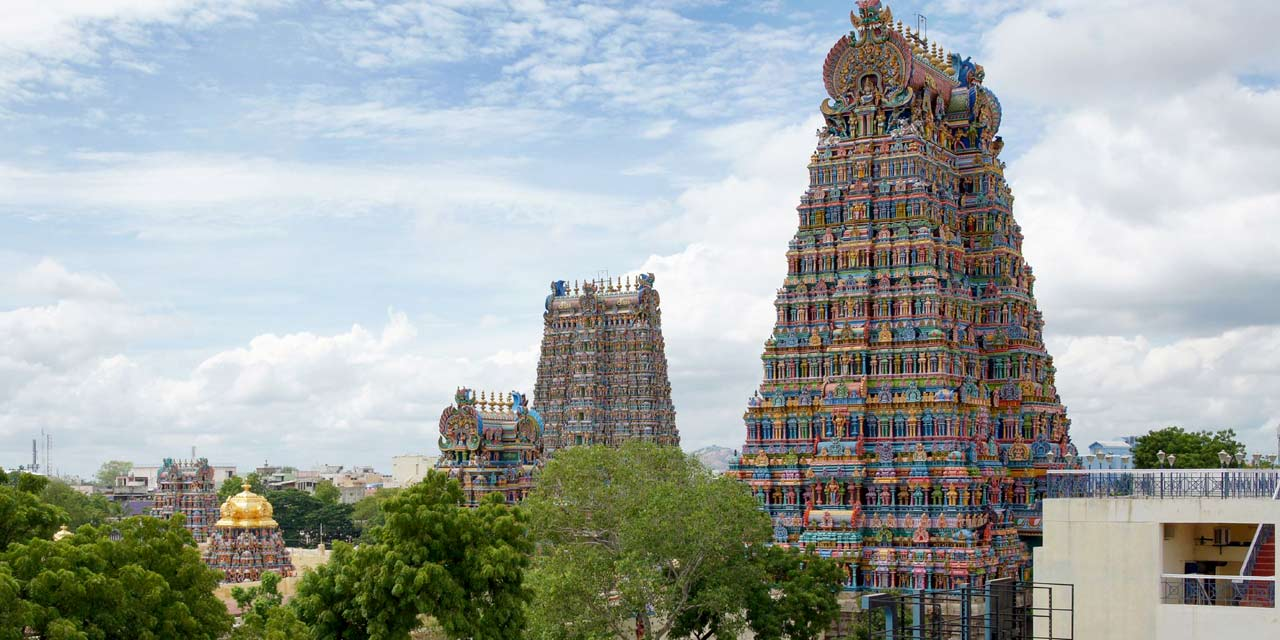Imagine a day in the life of one of the statues on the temple. What experiences would it have? As the sun rises, casting a warm glow on the temple’s facade, the statue watches the first devotees entering, their faces reflecting reverence and hope. It listens to the early morning chants and the gentle ringing of bells. During the day, it observes a continuous stream of visitors: children in awe of its form, elderly worshippers whispering prayers, and tourists marveling at its artistic details. It feels the caress of time as shadows shift around it. In the evening, it is bathed in the golden light of lamps and candles, partaking in the evening Aarti filled with music and devotion. The statue, though silent and still, lives vicariously through the countless lives that cross its path daily, absorbing fragments of prayers, conversations, and emotions, becoming a silent witness to humanity's search for the divine. 